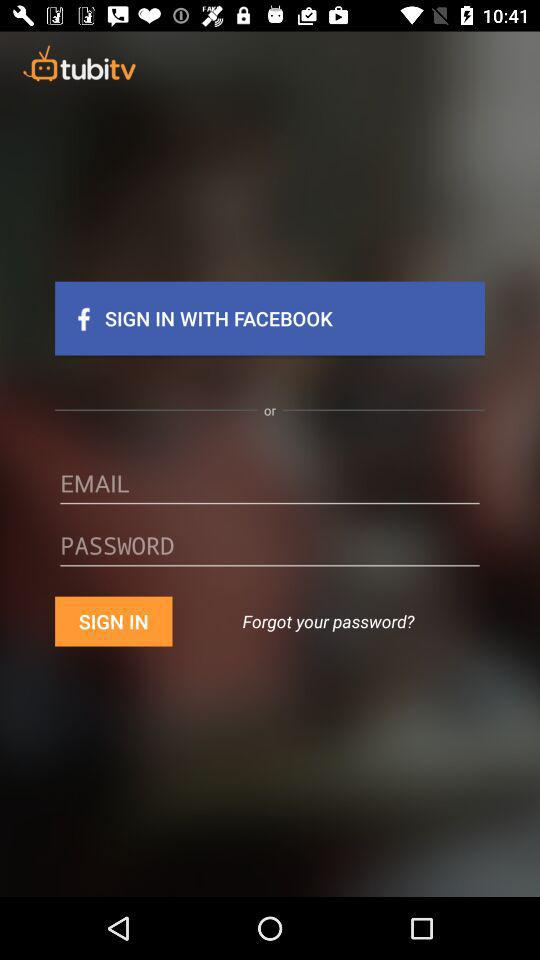What is the name of the application? The name of the application is "tubitv". 